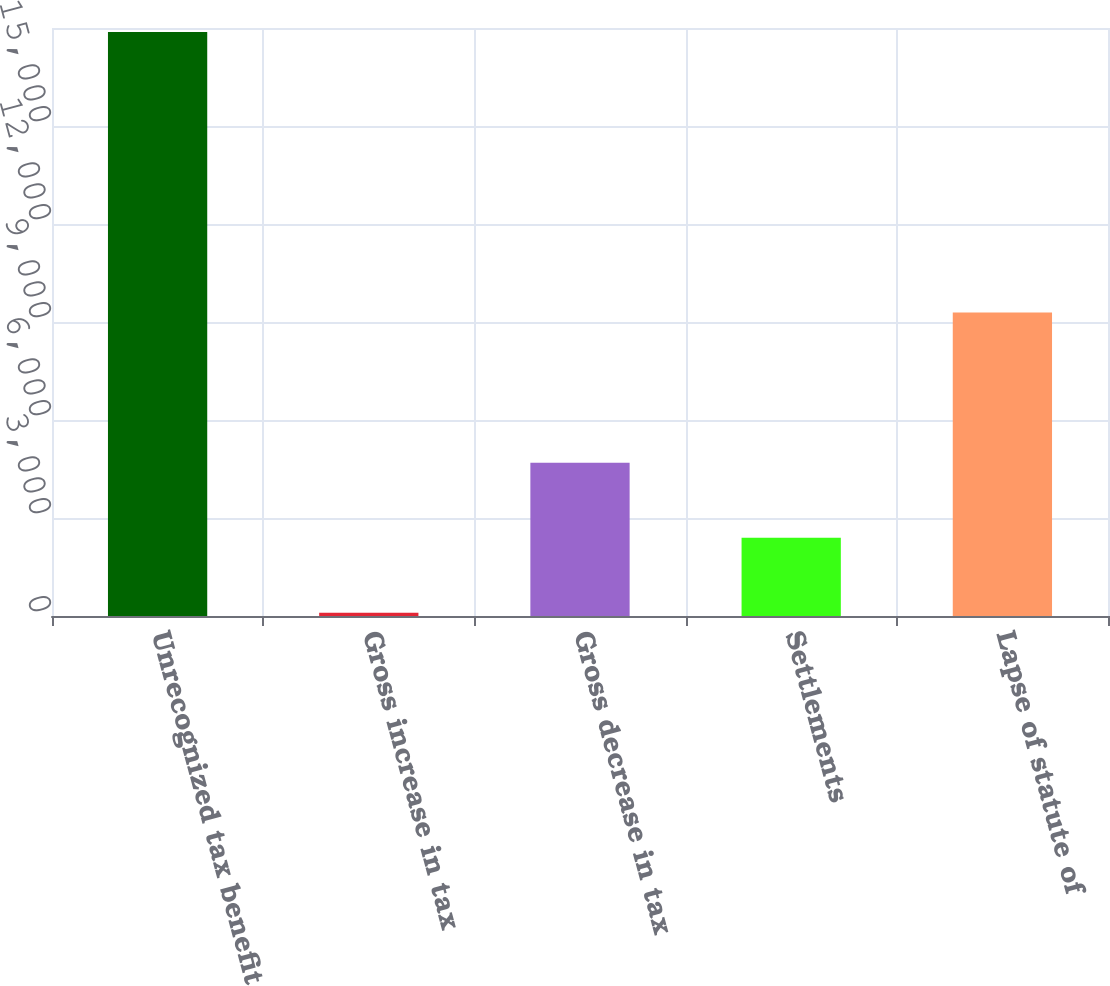Convert chart. <chart><loc_0><loc_0><loc_500><loc_500><bar_chart><fcel>Unrecognized tax benefit at<fcel>Gross increase in tax<fcel>Gross decrease in tax<fcel>Settlements<fcel>Lapse of statute of<nl><fcel>17877<fcel>97<fcel>4693.6<fcel>2395.3<fcel>9290.2<nl></chart> 